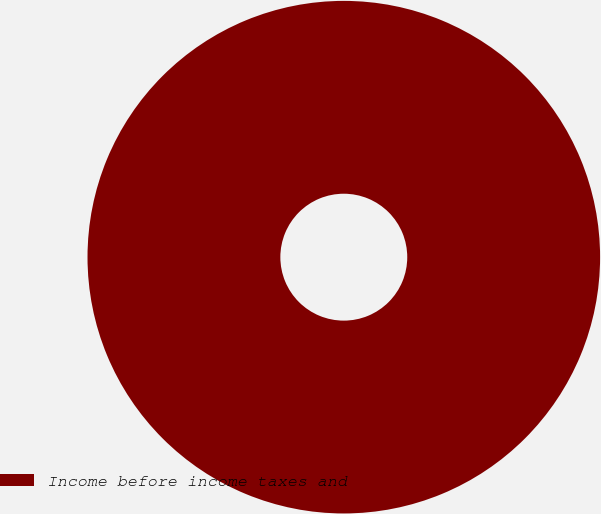Convert chart to OTSL. <chart><loc_0><loc_0><loc_500><loc_500><pie_chart><fcel>Income before income taxes and<nl><fcel>100.0%<nl></chart> 